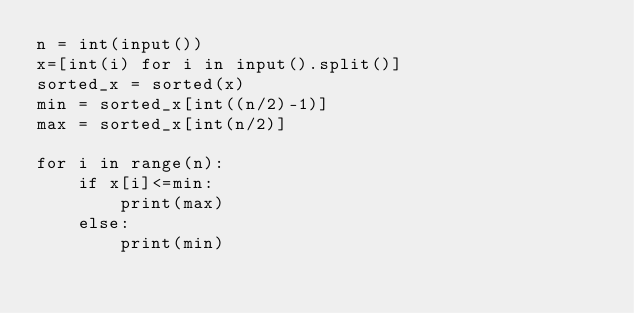Convert code to text. <code><loc_0><loc_0><loc_500><loc_500><_Python_>n = int(input())
x=[int(i) for i in input().split()]
sorted_x = sorted(x)
min = sorted_x[int((n/2)-1)]
max = sorted_x[int(n/2)] 

for i in range(n):
    if x[i]<=min:
        print(max)
    else:
        print(min)
</code> 